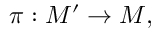Convert formula to latex. <formula><loc_0><loc_0><loc_500><loc_500>\pi \colon M ^ { \prime } \to M ,</formula> 